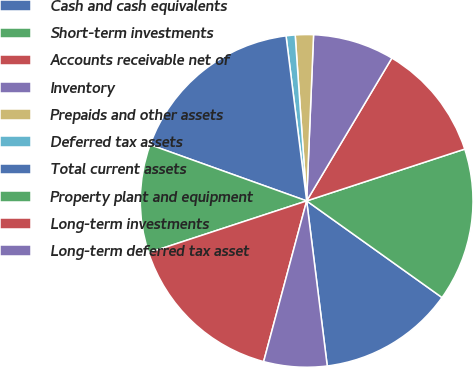<chart> <loc_0><loc_0><loc_500><loc_500><pie_chart><fcel>Cash and cash equivalents<fcel>Short-term investments<fcel>Accounts receivable net of<fcel>Inventory<fcel>Prepaids and other assets<fcel>Deferred tax assets<fcel>Total current assets<fcel>Property plant and equipment<fcel>Long-term investments<fcel>Long-term deferred tax asset<nl><fcel>13.16%<fcel>14.91%<fcel>11.4%<fcel>7.9%<fcel>1.76%<fcel>0.88%<fcel>17.54%<fcel>10.53%<fcel>15.79%<fcel>6.14%<nl></chart> 